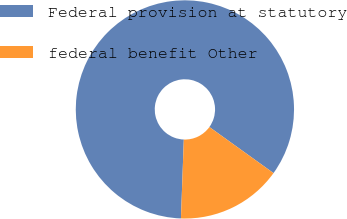<chart> <loc_0><loc_0><loc_500><loc_500><pie_chart><fcel>Federal provision at statutory<fcel>federal benefit Other<nl><fcel>84.34%<fcel>15.66%<nl></chart> 